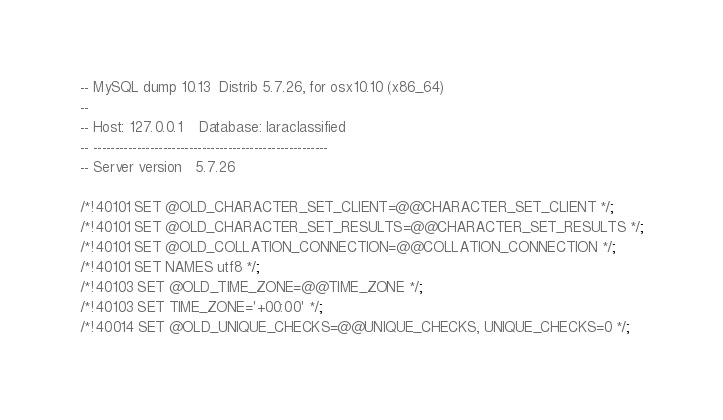Convert code to text. <code><loc_0><loc_0><loc_500><loc_500><_SQL_>-- MySQL dump 10.13  Distrib 5.7.26, for osx10.10 (x86_64)
--
-- Host: 127.0.0.1    Database: laraclassified
-- ------------------------------------------------------
-- Server version	5.7.26

/*!40101 SET @OLD_CHARACTER_SET_CLIENT=@@CHARACTER_SET_CLIENT */;
/*!40101 SET @OLD_CHARACTER_SET_RESULTS=@@CHARACTER_SET_RESULTS */;
/*!40101 SET @OLD_COLLATION_CONNECTION=@@COLLATION_CONNECTION */;
/*!40101 SET NAMES utf8 */;
/*!40103 SET @OLD_TIME_ZONE=@@TIME_ZONE */;
/*!40103 SET TIME_ZONE='+00:00' */;
/*!40014 SET @OLD_UNIQUE_CHECKS=@@UNIQUE_CHECKS, UNIQUE_CHECKS=0 */;</code> 